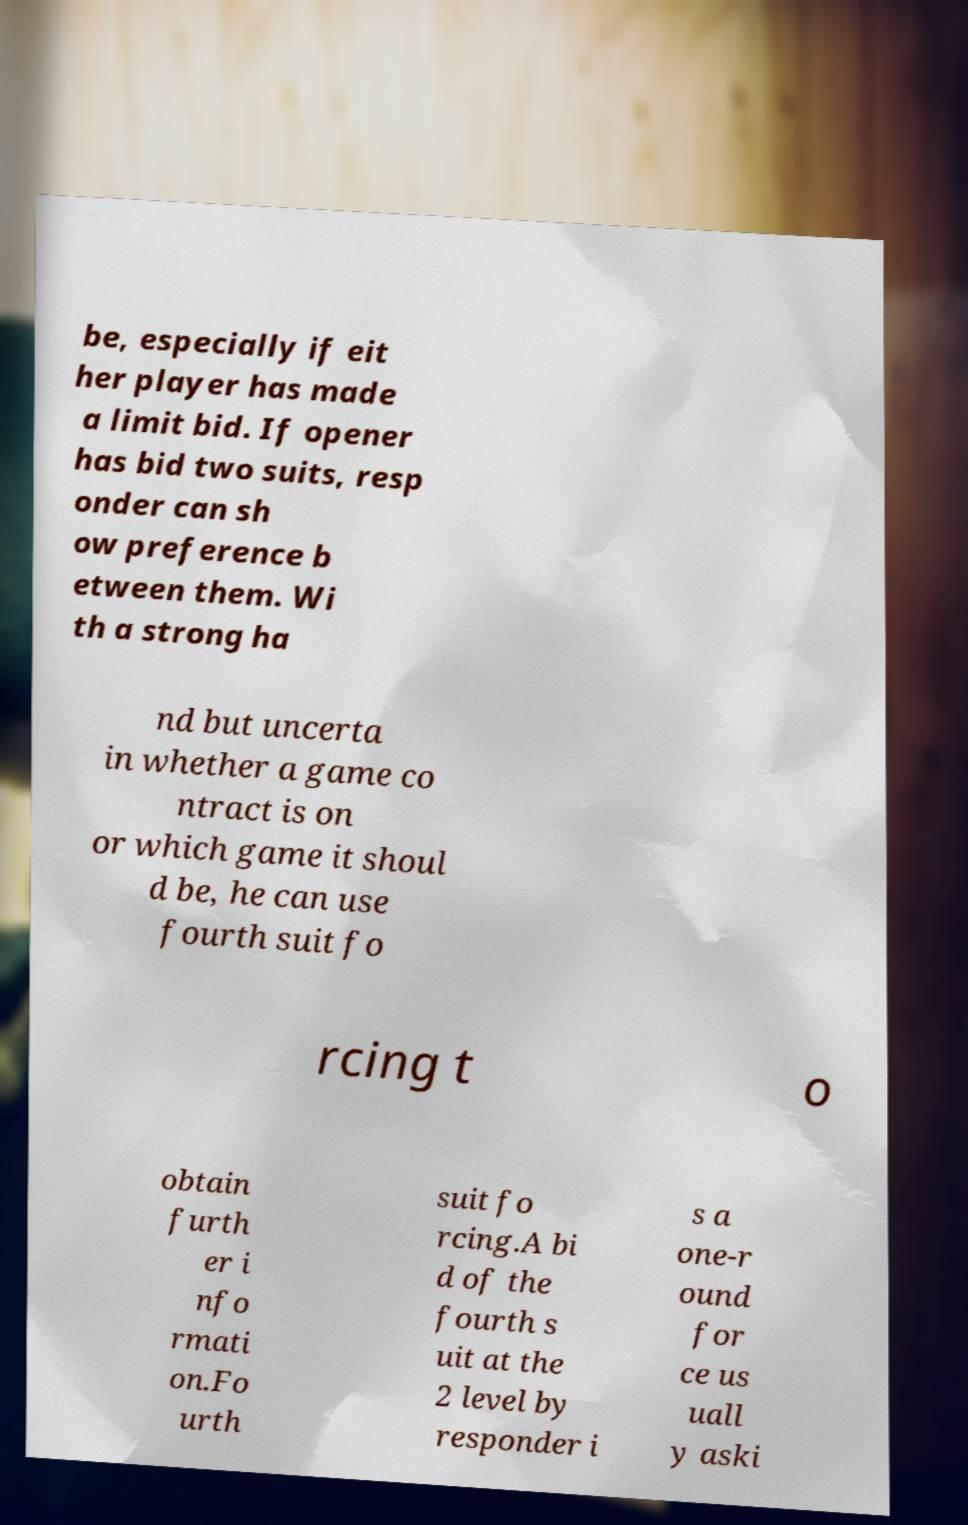For documentation purposes, I need the text within this image transcribed. Could you provide that? be, especially if eit her player has made a limit bid. If opener has bid two suits, resp onder can sh ow preference b etween them. Wi th a strong ha nd but uncerta in whether a game co ntract is on or which game it shoul d be, he can use fourth suit fo rcing t o obtain furth er i nfo rmati on.Fo urth suit fo rcing.A bi d of the fourth s uit at the 2 level by responder i s a one-r ound for ce us uall y aski 